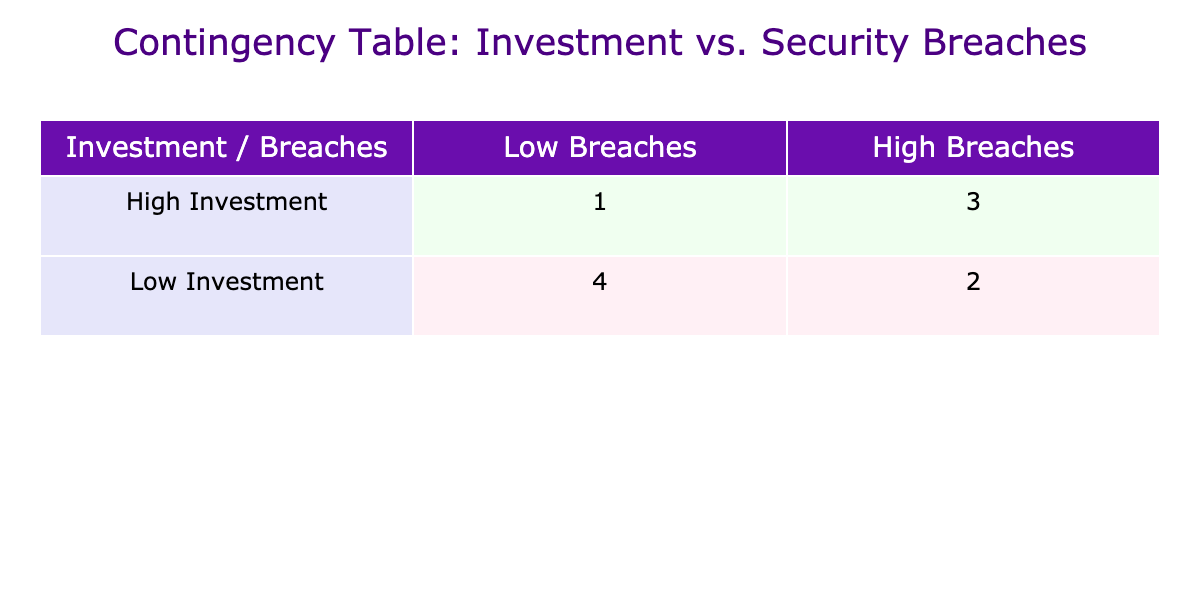What is the number of companies with high security breaches and high investment in cybersecurity measures? From the table, we can see the counts of companies are categorized into 'High' and 'High' for both security breaches and investment. Based on the contingency table: there is 1 company that fits this category.
Answer: 1 How many companies have low investment in cybersecurity measures and low security breaches? The table indicates the counts for companies that fall into the 'Low' category for both investment and breaches. There are 2 such companies according to the contingency table.
Answer: 2 Which category has more companies: high investment with low breaches or low investment with high breaches? By checking the numbers, the high investment with low breaches category has 1 company while the low investment with high breaches category has 2 companies. Therefore, low investment with high breaches is greater.
Answer: Low investment with high breaches What is the total number of companies that invested more than the average investment? The average investment calculated from the data is 1330000. Companies that invested over this average are counted: TechCorp, FinSecure, AutoInnovate, GamingZone. This totals to 4 companies.
Answer: 4 Is it true that all companies having high security breaches invested more than 1 million in cybersecurity measures? Reviewing the data, we notice that the company HealthGuard has 10 security breaches but invested only 1200000, which is above 1 million. However, we check all high breach companies, and none invested less than this threshold. Thus, the statement is true.
Answer: True How many companies with low investment have high security breaches? From the contingency table, it shows there are 2 companies with low investment that also fall into the high breach category. This can be quickly verified through the data.
Answer: 2 What is the difference in the number of companies between high breaches and low breaches with high investments? The high breaches side has 1 company, and the low breaches side has 1 company, so the difference is zero as they are equal.
Answer: 0 How many total breaches are recorded in companies with high investment in cybersecurity measures? From the companies categorized under high investment, we have TechCorp (5), FinSecure (3), AutoInnovate (6), GamingZone (7), totaling 21 breaches. This requires summing these values: 5 + 3 + 6 + 7 = 21.
Answer: 21 